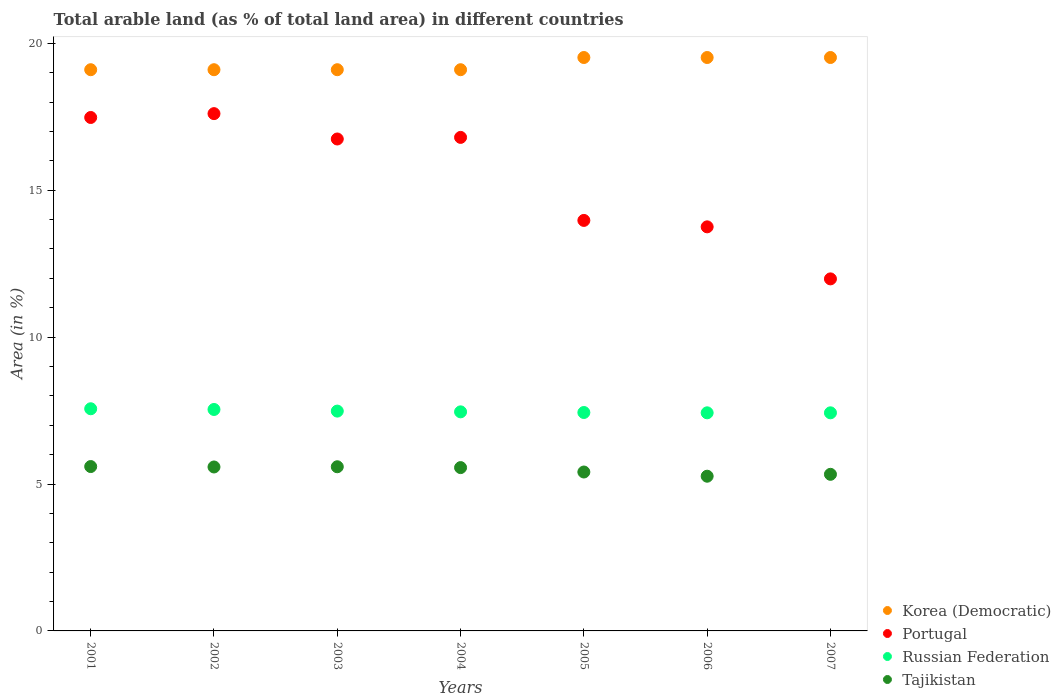What is the percentage of arable land in Korea (Democratic) in 2001?
Give a very brief answer. 19.1. Across all years, what is the maximum percentage of arable land in Tajikistan?
Give a very brief answer. 5.59. Across all years, what is the minimum percentage of arable land in Russian Federation?
Offer a terse response. 7.42. In which year was the percentage of arable land in Portugal maximum?
Offer a terse response. 2002. In which year was the percentage of arable land in Korea (Democratic) minimum?
Your response must be concise. 2001. What is the total percentage of arable land in Tajikistan in the graph?
Make the answer very short. 38.33. What is the difference between the percentage of arable land in Russian Federation in 2006 and that in 2007?
Give a very brief answer. 0. What is the difference between the percentage of arable land in Russian Federation in 2004 and the percentage of arable land in Portugal in 2001?
Keep it short and to the point. -10.02. What is the average percentage of arable land in Russian Federation per year?
Give a very brief answer. 7.47. In the year 2007, what is the difference between the percentage of arable land in Portugal and percentage of arable land in Korea (Democratic)?
Ensure brevity in your answer.  -7.53. In how many years, is the percentage of arable land in Russian Federation greater than 9 %?
Offer a terse response. 0. What is the ratio of the percentage of arable land in Korea (Democratic) in 2004 to that in 2005?
Your answer should be compact. 0.98. Is the percentage of arable land in Russian Federation in 2004 less than that in 2006?
Your answer should be very brief. No. What is the difference between the highest and the second highest percentage of arable land in Tajikistan?
Make the answer very short. 0.01. What is the difference between the highest and the lowest percentage of arable land in Tajikistan?
Keep it short and to the point. 0.33. Does the percentage of arable land in Russian Federation monotonically increase over the years?
Provide a short and direct response. No. Is the percentage of arable land in Tajikistan strictly less than the percentage of arable land in Russian Federation over the years?
Your response must be concise. Yes. What is the difference between two consecutive major ticks on the Y-axis?
Provide a succinct answer. 5. Does the graph contain any zero values?
Ensure brevity in your answer.  No. Where does the legend appear in the graph?
Offer a terse response. Bottom right. How many legend labels are there?
Your answer should be compact. 4. What is the title of the graph?
Your answer should be very brief. Total arable land (as % of total land area) in different countries. What is the label or title of the Y-axis?
Ensure brevity in your answer.  Area (in %). What is the Area (in %) in Korea (Democratic) in 2001?
Your answer should be compact. 19.1. What is the Area (in %) of Portugal in 2001?
Offer a very short reply. 17.48. What is the Area (in %) in Russian Federation in 2001?
Offer a very short reply. 7.56. What is the Area (in %) in Tajikistan in 2001?
Keep it short and to the point. 5.59. What is the Area (in %) in Korea (Democratic) in 2002?
Keep it short and to the point. 19.1. What is the Area (in %) of Portugal in 2002?
Your response must be concise. 17.61. What is the Area (in %) of Russian Federation in 2002?
Your answer should be very brief. 7.54. What is the Area (in %) of Tajikistan in 2002?
Offer a very short reply. 5.58. What is the Area (in %) in Korea (Democratic) in 2003?
Keep it short and to the point. 19.1. What is the Area (in %) in Portugal in 2003?
Give a very brief answer. 16.74. What is the Area (in %) of Russian Federation in 2003?
Provide a succinct answer. 7.48. What is the Area (in %) of Tajikistan in 2003?
Your answer should be very brief. 5.59. What is the Area (in %) in Korea (Democratic) in 2004?
Ensure brevity in your answer.  19.1. What is the Area (in %) of Portugal in 2004?
Keep it short and to the point. 16.8. What is the Area (in %) of Russian Federation in 2004?
Offer a very short reply. 7.46. What is the Area (in %) in Tajikistan in 2004?
Your answer should be compact. 5.56. What is the Area (in %) in Korea (Democratic) in 2005?
Make the answer very short. 19.52. What is the Area (in %) of Portugal in 2005?
Provide a succinct answer. 13.97. What is the Area (in %) of Russian Federation in 2005?
Ensure brevity in your answer.  7.43. What is the Area (in %) in Tajikistan in 2005?
Give a very brief answer. 5.41. What is the Area (in %) in Korea (Democratic) in 2006?
Provide a succinct answer. 19.52. What is the Area (in %) of Portugal in 2006?
Offer a very short reply. 13.75. What is the Area (in %) in Russian Federation in 2006?
Your response must be concise. 7.42. What is the Area (in %) in Tajikistan in 2006?
Your response must be concise. 5.27. What is the Area (in %) in Korea (Democratic) in 2007?
Give a very brief answer. 19.52. What is the Area (in %) in Portugal in 2007?
Ensure brevity in your answer.  11.98. What is the Area (in %) of Russian Federation in 2007?
Ensure brevity in your answer.  7.42. What is the Area (in %) in Tajikistan in 2007?
Offer a very short reply. 5.33. Across all years, what is the maximum Area (in %) in Korea (Democratic)?
Your answer should be compact. 19.52. Across all years, what is the maximum Area (in %) of Portugal?
Your response must be concise. 17.61. Across all years, what is the maximum Area (in %) in Russian Federation?
Provide a succinct answer. 7.56. Across all years, what is the maximum Area (in %) in Tajikistan?
Provide a short and direct response. 5.59. Across all years, what is the minimum Area (in %) of Korea (Democratic)?
Offer a terse response. 19.1. Across all years, what is the minimum Area (in %) of Portugal?
Provide a short and direct response. 11.98. Across all years, what is the minimum Area (in %) in Russian Federation?
Offer a very short reply. 7.42. Across all years, what is the minimum Area (in %) in Tajikistan?
Ensure brevity in your answer.  5.27. What is the total Area (in %) of Korea (Democratic) in the graph?
Offer a terse response. 134.96. What is the total Area (in %) in Portugal in the graph?
Offer a terse response. 108.33. What is the total Area (in %) of Russian Federation in the graph?
Your answer should be very brief. 52.32. What is the total Area (in %) of Tajikistan in the graph?
Your response must be concise. 38.33. What is the difference between the Area (in %) in Portugal in 2001 and that in 2002?
Your response must be concise. -0.13. What is the difference between the Area (in %) of Russian Federation in 2001 and that in 2002?
Provide a succinct answer. 0.02. What is the difference between the Area (in %) in Tajikistan in 2001 and that in 2002?
Your answer should be compact. 0.01. What is the difference between the Area (in %) of Korea (Democratic) in 2001 and that in 2003?
Make the answer very short. 0. What is the difference between the Area (in %) of Portugal in 2001 and that in 2003?
Ensure brevity in your answer.  0.73. What is the difference between the Area (in %) in Russian Federation in 2001 and that in 2003?
Keep it short and to the point. 0.08. What is the difference between the Area (in %) of Tajikistan in 2001 and that in 2003?
Ensure brevity in your answer.  0.01. What is the difference between the Area (in %) of Korea (Democratic) in 2001 and that in 2004?
Your answer should be compact. 0. What is the difference between the Area (in %) of Portugal in 2001 and that in 2004?
Make the answer very short. 0.68. What is the difference between the Area (in %) in Russian Federation in 2001 and that in 2004?
Your response must be concise. 0.1. What is the difference between the Area (in %) of Tajikistan in 2001 and that in 2004?
Make the answer very short. 0.04. What is the difference between the Area (in %) in Korea (Democratic) in 2001 and that in 2005?
Your response must be concise. -0.42. What is the difference between the Area (in %) of Portugal in 2001 and that in 2005?
Offer a terse response. 3.5. What is the difference between the Area (in %) of Russian Federation in 2001 and that in 2005?
Provide a succinct answer. 0.13. What is the difference between the Area (in %) of Tajikistan in 2001 and that in 2005?
Ensure brevity in your answer.  0.19. What is the difference between the Area (in %) of Korea (Democratic) in 2001 and that in 2006?
Offer a terse response. -0.42. What is the difference between the Area (in %) in Portugal in 2001 and that in 2006?
Ensure brevity in your answer.  3.72. What is the difference between the Area (in %) in Russian Federation in 2001 and that in 2006?
Ensure brevity in your answer.  0.14. What is the difference between the Area (in %) of Tajikistan in 2001 and that in 2006?
Offer a terse response. 0.33. What is the difference between the Area (in %) in Korea (Democratic) in 2001 and that in 2007?
Give a very brief answer. -0.42. What is the difference between the Area (in %) in Portugal in 2001 and that in 2007?
Your answer should be compact. 5.49. What is the difference between the Area (in %) in Russian Federation in 2001 and that in 2007?
Provide a succinct answer. 0.14. What is the difference between the Area (in %) in Tajikistan in 2001 and that in 2007?
Provide a short and direct response. 0.26. What is the difference between the Area (in %) of Portugal in 2002 and that in 2003?
Your answer should be compact. 0.86. What is the difference between the Area (in %) of Russian Federation in 2002 and that in 2003?
Provide a short and direct response. 0.06. What is the difference between the Area (in %) of Tajikistan in 2002 and that in 2003?
Make the answer very short. -0.01. What is the difference between the Area (in %) of Korea (Democratic) in 2002 and that in 2004?
Offer a very short reply. 0. What is the difference between the Area (in %) of Portugal in 2002 and that in 2004?
Provide a succinct answer. 0.81. What is the difference between the Area (in %) in Russian Federation in 2002 and that in 2004?
Provide a short and direct response. 0.08. What is the difference between the Area (in %) in Tajikistan in 2002 and that in 2004?
Your answer should be very brief. 0.02. What is the difference between the Area (in %) in Korea (Democratic) in 2002 and that in 2005?
Provide a succinct answer. -0.42. What is the difference between the Area (in %) in Portugal in 2002 and that in 2005?
Keep it short and to the point. 3.63. What is the difference between the Area (in %) of Russian Federation in 2002 and that in 2005?
Your answer should be compact. 0.1. What is the difference between the Area (in %) in Tajikistan in 2002 and that in 2005?
Provide a succinct answer. 0.17. What is the difference between the Area (in %) in Korea (Democratic) in 2002 and that in 2006?
Make the answer very short. -0.42. What is the difference between the Area (in %) in Portugal in 2002 and that in 2006?
Offer a very short reply. 3.85. What is the difference between the Area (in %) in Russian Federation in 2002 and that in 2006?
Your response must be concise. 0.11. What is the difference between the Area (in %) of Tajikistan in 2002 and that in 2006?
Make the answer very short. 0.31. What is the difference between the Area (in %) of Korea (Democratic) in 2002 and that in 2007?
Offer a terse response. -0.42. What is the difference between the Area (in %) of Portugal in 2002 and that in 2007?
Your answer should be very brief. 5.62. What is the difference between the Area (in %) of Russian Federation in 2002 and that in 2007?
Your answer should be compact. 0.11. What is the difference between the Area (in %) of Tajikistan in 2002 and that in 2007?
Offer a terse response. 0.25. What is the difference between the Area (in %) of Korea (Democratic) in 2003 and that in 2004?
Ensure brevity in your answer.  0. What is the difference between the Area (in %) in Portugal in 2003 and that in 2004?
Give a very brief answer. -0.05. What is the difference between the Area (in %) of Russian Federation in 2003 and that in 2004?
Offer a very short reply. 0.03. What is the difference between the Area (in %) in Tajikistan in 2003 and that in 2004?
Make the answer very short. 0.03. What is the difference between the Area (in %) in Korea (Democratic) in 2003 and that in 2005?
Keep it short and to the point. -0.42. What is the difference between the Area (in %) in Portugal in 2003 and that in 2005?
Your answer should be compact. 2.77. What is the difference between the Area (in %) in Russian Federation in 2003 and that in 2005?
Your response must be concise. 0.05. What is the difference between the Area (in %) in Tajikistan in 2003 and that in 2005?
Your answer should be very brief. 0.18. What is the difference between the Area (in %) in Korea (Democratic) in 2003 and that in 2006?
Offer a very short reply. -0.42. What is the difference between the Area (in %) of Portugal in 2003 and that in 2006?
Give a very brief answer. 2.99. What is the difference between the Area (in %) in Russian Federation in 2003 and that in 2006?
Make the answer very short. 0.06. What is the difference between the Area (in %) in Tajikistan in 2003 and that in 2006?
Ensure brevity in your answer.  0.32. What is the difference between the Area (in %) of Korea (Democratic) in 2003 and that in 2007?
Provide a short and direct response. -0.42. What is the difference between the Area (in %) in Portugal in 2003 and that in 2007?
Your response must be concise. 4.76. What is the difference between the Area (in %) in Russian Federation in 2003 and that in 2007?
Offer a terse response. 0.06. What is the difference between the Area (in %) in Tajikistan in 2003 and that in 2007?
Provide a succinct answer. 0.26. What is the difference between the Area (in %) in Korea (Democratic) in 2004 and that in 2005?
Offer a terse response. -0.42. What is the difference between the Area (in %) in Portugal in 2004 and that in 2005?
Your answer should be compact. 2.83. What is the difference between the Area (in %) of Russian Federation in 2004 and that in 2005?
Provide a succinct answer. 0.02. What is the difference between the Area (in %) in Tajikistan in 2004 and that in 2005?
Your answer should be compact. 0.15. What is the difference between the Area (in %) in Korea (Democratic) in 2004 and that in 2006?
Your response must be concise. -0.42. What is the difference between the Area (in %) of Portugal in 2004 and that in 2006?
Ensure brevity in your answer.  3.04. What is the difference between the Area (in %) in Russian Federation in 2004 and that in 2006?
Give a very brief answer. 0.03. What is the difference between the Area (in %) of Tajikistan in 2004 and that in 2006?
Offer a terse response. 0.29. What is the difference between the Area (in %) in Korea (Democratic) in 2004 and that in 2007?
Offer a terse response. -0.42. What is the difference between the Area (in %) in Portugal in 2004 and that in 2007?
Provide a succinct answer. 4.82. What is the difference between the Area (in %) of Tajikistan in 2004 and that in 2007?
Make the answer very short. 0.23. What is the difference between the Area (in %) of Korea (Democratic) in 2005 and that in 2006?
Provide a succinct answer. 0. What is the difference between the Area (in %) in Portugal in 2005 and that in 2006?
Offer a very short reply. 0.22. What is the difference between the Area (in %) of Russian Federation in 2005 and that in 2006?
Ensure brevity in your answer.  0.01. What is the difference between the Area (in %) in Tajikistan in 2005 and that in 2006?
Provide a succinct answer. 0.14. What is the difference between the Area (in %) of Portugal in 2005 and that in 2007?
Your answer should be very brief. 1.99. What is the difference between the Area (in %) in Russian Federation in 2005 and that in 2007?
Provide a short and direct response. 0.01. What is the difference between the Area (in %) of Tajikistan in 2005 and that in 2007?
Offer a very short reply. 0.08. What is the difference between the Area (in %) of Portugal in 2006 and that in 2007?
Ensure brevity in your answer.  1.77. What is the difference between the Area (in %) of Russian Federation in 2006 and that in 2007?
Your answer should be very brief. 0. What is the difference between the Area (in %) in Tajikistan in 2006 and that in 2007?
Your response must be concise. -0.06. What is the difference between the Area (in %) in Korea (Democratic) in 2001 and the Area (in %) in Portugal in 2002?
Provide a succinct answer. 1.49. What is the difference between the Area (in %) of Korea (Democratic) in 2001 and the Area (in %) of Russian Federation in 2002?
Your answer should be compact. 11.56. What is the difference between the Area (in %) of Korea (Democratic) in 2001 and the Area (in %) of Tajikistan in 2002?
Provide a succinct answer. 13.52. What is the difference between the Area (in %) in Portugal in 2001 and the Area (in %) in Russian Federation in 2002?
Offer a terse response. 9.94. What is the difference between the Area (in %) in Portugal in 2001 and the Area (in %) in Tajikistan in 2002?
Your answer should be compact. 11.9. What is the difference between the Area (in %) in Russian Federation in 2001 and the Area (in %) in Tajikistan in 2002?
Offer a very short reply. 1.98. What is the difference between the Area (in %) in Korea (Democratic) in 2001 and the Area (in %) in Portugal in 2003?
Make the answer very short. 2.36. What is the difference between the Area (in %) of Korea (Democratic) in 2001 and the Area (in %) of Russian Federation in 2003?
Provide a short and direct response. 11.62. What is the difference between the Area (in %) in Korea (Democratic) in 2001 and the Area (in %) in Tajikistan in 2003?
Your answer should be compact. 13.51. What is the difference between the Area (in %) in Portugal in 2001 and the Area (in %) in Russian Federation in 2003?
Ensure brevity in your answer.  9.99. What is the difference between the Area (in %) of Portugal in 2001 and the Area (in %) of Tajikistan in 2003?
Offer a terse response. 11.89. What is the difference between the Area (in %) of Russian Federation in 2001 and the Area (in %) of Tajikistan in 2003?
Keep it short and to the point. 1.97. What is the difference between the Area (in %) in Korea (Democratic) in 2001 and the Area (in %) in Portugal in 2004?
Your answer should be very brief. 2.3. What is the difference between the Area (in %) of Korea (Democratic) in 2001 and the Area (in %) of Russian Federation in 2004?
Give a very brief answer. 11.64. What is the difference between the Area (in %) of Korea (Democratic) in 2001 and the Area (in %) of Tajikistan in 2004?
Your answer should be compact. 13.54. What is the difference between the Area (in %) of Portugal in 2001 and the Area (in %) of Russian Federation in 2004?
Provide a short and direct response. 10.02. What is the difference between the Area (in %) in Portugal in 2001 and the Area (in %) in Tajikistan in 2004?
Provide a succinct answer. 11.92. What is the difference between the Area (in %) of Russian Federation in 2001 and the Area (in %) of Tajikistan in 2004?
Your response must be concise. 2. What is the difference between the Area (in %) of Korea (Democratic) in 2001 and the Area (in %) of Portugal in 2005?
Ensure brevity in your answer.  5.13. What is the difference between the Area (in %) of Korea (Democratic) in 2001 and the Area (in %) of Russian Federation in 2005?
Offer a terse response. 11.67. What is the difference between the Area (in %) in Korea (Democratic) in 2001 and the Area (in %) in Tajikistan in 2005?
Your response must be concise. 13.69. What is the difference between the Area (in %) in Portugal in 2001 and the Area (in %) in Russian Federation in 2005?
Provide a succinct answer. 10.04. What is the difference between the Area (in %) in Portugal in 2001 and the Area (in %) in Tajikistan in 2005?
Make the answer very short. 12.07. What is the difference between the Area (in %) of Russian Federation in 2001 and the Area (in %) of Tajikistan in 2005?
Your answer should be very brief. 2.15. What is the difference between the Area (in %) of Korea (Democratic) in 2001 and the Area (in %) of Portugal in 2006?
Offer a very short reply. 5.35. What is the difference between the Area (in %) of Korea (Democratic) in 2001 and the Area (in %) of Russian Federation in 2006?
Offer a very short reply. 11.68. What is the difference between the Area (in %) in Korea (Democratic) in 2001 and the Area (in %) in Tajikistan in 2006?
Ensure brevity in your answer.  13.84. What is the difference between the Area (in %) of Portugal in 2001 and the Area (in %) of Russian Federation in 2006?
Keep it short and to the point. 10.05. What is the difference between the Area (in %) of Portugal in 2001 and the Area (in %) of Tajikistan in 2006?
Your response must be concise. 12.21. What is the difference between the Area (in %) of Russian Federation in 2001 and the Area (in %) of Tajikistan in 2006?
Provide a succinct answer. 2.3. What is the difference between the Area (in %) in Korea (Democratic) in 2001 and the Area (in %) in Portugal in 2007?
Make the answer very short. 7.12. What is the difference between the Area (in %) in Korea (Democratic) in 2001 and the Area (in %) in Russian Federation in 2007?
Your answer should be compact. 11.68. What is the difference between the Area (in %) in Korea (Democratic) in 2001 and the Area (in %) in Tajikistan in 2007?
Provide a short and direct response. 13.77. What is the difference between the Area (in %) in Portugal in 2001 and the Area (in %) in Russian Federation in 2007?
Your answer should be very brief. 10.05. What is the difference between the Area (in %) of Portugal in 2001 and the Area (in %) of Tajikistan in 2007?
Offer a very short reply. 12.15. What is the difference between the Area (in %) of Russian Federation in 2001 and the Area (in %) of Tajikistan in 2007?
Provide a succinct answer. 2.23. What is the difference between the Area (in %) in Korea (Democratic) in 2002 and the Area (in %) in Portugal in 2003?
Provide a succinct answer. 2.36. What is the difference between the Area (in %) in Korea (Democratic) in 2002 and the Area (in %) in Russian Federation in 2003?
Offer a terse response. 11.62. What is the difference between the Area (in %) of Korea (Democratic) in 2002 and the Area (in %) of Tajikistan in 2003?
Keep it short and to the point. 13.51. What is the difference between the Area (in %) of Portugal in 2002 and the Area (in %) of Russian Federation in 2003?
Keep it short and to the point. 10.12. What is the difference between the Area (in %) of Portugal in 2002 and the Area (in %) of Tajikistan in 2003?
Provide a succinct answer. 12.02. What is the difference between the Area (in %) in Russian Federation in 2002 and the Area (in %) in Tajikistan in 2003?
Your response must be concise. 1.95. What is the difference between the Area (in %) in Korea (Democratic) in 2002 and the Area (in %) in Portugal in 2004?
Offer a terse response. 2.3. What is the difference between the Area (in %) in Korea (Democratic) in 2002 and the Area (in %) in Russian Federation in 2004?
Your answer should be compact. 11.64. What is the difference between the Area (in %) in Korea (Democratic) in 2002 and the Area (in %) in Tajikistan in 2004?
Provide a short and direct response. 13.54. What is the difference between the Area (in %) of Portugal in 2002 and the Area (in %) of Russian Federation in 2004?
Keep it short and to the point. 10.15. What is the difference between the Area (in %) in Portugal in 2002 and the Area (in %) in Tajikistan in 2004?
Your response must be concise. 12.05. What is the difference between the Area (in %) in Russian Federation in 2002 and the Area (in %) in Tajikistan in 2004?
Make the answer very short. 1.98. What is the difference between the Area (in %) of Korea (Democratic) in 2002 and the Area (in %) of Portugal in 2005?
Your answer should be compact. 5.13. What is the difference between the Area (in %) in Korea (Democratic) in 2002 and the Area (in %) in Russian Federation in 2005?
Ensure brevity in your answer.  11.67. What is the difference between the Area (in %) in Korea (Democratic) in 2002 and the Area (in %) in Tajikistan in 2005?
Ensure brevity in your answer.  13.69. What is the difference between the Area (in %) of Portugal in 2002 and the Area (in %) of Russian Federation in 2005?
Make the answer very short. 10.17. What is the difference between the Area (in %) of Portugal in 2002 and the Area (in %) of Tajikistan in 2005?
Give a very brief answer. 12.2. What is the difference between the Area (in %) in Russian Federation in 2002 and the Area (in %) in Tajikistan in 2005?
Provide a succinct answer. 2.13. What is the difference between the Area (in %) in Korea (Democratic) in 2002 and the Area (in %) in Portugal in 2006?
Your answer should be compact. 5.35. What is the difference between the Area (in %) in Korea (Democratic) in 2002 and the Area (in %) in Russian Federation in 2006?
Offer a terse response. 11.68. What is the difference between the Area (in %) in Korea (Democratic) in 2002 and the Area (in %) in Tajikistan in 2006?
Provide a short and direct response. 13.84. What is the difference between the Area (in %) in Portugal in 2002 and the Area (in %) in Russian Federation in 2006?
Provide a succinct answer. 10.18. What is the difference between the Area (in %) in Portugal in 2002 and the Area (in %) in Tajikistan in 2006?
Offer a terse response. 12.34. What is the difference between the Area (in %) of Russian Federation in 2002 and the Area (in %) of Tajikistan in 2006?
Offer a very short reply. 2.27. What is the difference between the Area (in %) in Korea (Democratic) in 2002 and the Area (in %) in Portugal in 2007?
Your answer should be compact. 7.12. What is the difference between the Area (in %) in Korea (Democratic) in 2002 and the Area (in %) in Russian Federation in 2007?
Your answer should be compact. 11.68. What is the difference between the Area (in %) in Korea (Democratic) in 2002 and the Area (in %) in Tajikistan in 2007?
Provide a succinct answer. 13.77. What is the difference between the Area (in %) of Portugal in 2002 and the Area (in %) of Russian Federation in 2007?
Make the answer very short. 10.18. What is the difference between the Area (in %) in Portugal in 2002 and the Area (in %) in Tajikistan in 2007?
Offer a terse response. 12.28. What is the difference between the Area (in %) in Russian Federation in 2002 and the Area (in %) in Tajikistan in 2007?
Give a very brief answer. 2.21. What is the difference between the Area (in %) of Korea (Democratic) in 2003 and the Area (in %) of Portugal in 2004?
Make the answer very short. 2.3. What is the difference between the Area (in %) of Korea (Democratic) in 2003 and the Area (in %) of Russian Federation in 2004?
Keep it short and to the point. 11.64. What is the difference between the Area (in %) of Korea (Democratic) in 2003 and the Area (in %) of Tajikistan in 2004?
Provide a short and direct response. 13.54. What is the difference between the Area (in %) in Portugal in 2003 and the Area (in %) in Russian Federation in 2004?
Provide a succinct answer. 9.29. What is the difference between the Area (in %) of Portugal in 2003 and the Area (in %) of Tajikistan in 2004?
Offer a very short reply. 11.18. What is the difference between the Area (in %) in Russian Federation in 2003 and the Area (in %) in Tajikistan in 2004?
Offer a terse response. 1.92. What is the difference between the Area (in %) in Korea (Democratic) in 2003 and the Area (in %) in Portugal in 2005?
Give a very brief answer. 5.13. What is the difference between the Area (in %) in Korea (Democratic) in 2003 and the Area (in %) in Russian Federation in 2005?
Provide a short and direct response. 11.67. What is the difference between the Area (in %) in Korea (Democratic) in 2003 and the Area (in %) in Tajikistan in 2005?
Your response must be concise. 13.69. What is the difference between the Area (in %) of Portugal in 2003 and the Area (in %) of Russian Federation in 2005?
Make the answer very short. 9.31. What is the difference between the Area (in %) of Portugal in 2003 and the Area (in %) of Tajikistan in 2005?
Your response must be concise. 11.33. What is the difference between the Area (in %) in Russian Federation in 2003 and the Area (in %) in Tajikistan in 2005?
Provide a succinct answer. 2.07. What is the difference between the Area (in %) of Korea (Democratic) in 2003 and the Area (in %) of Portugal in 2006?
Offer a terse response. 5.35. What is the difference between the Area (in %) of Korea (Democratic) in 2003 and the Area (in %) of Russian Federation in 2006?
Your answer should be very brief. 11.68. What is the difference between the Area (in %) in Korea (Democratic) in 2003 and the Area (in %) in Tajikistan in 2006?
Offer a very short reply. 13.84. What is the difference between the Area (in %) of Portugal in 2003 and the Area (in %) of Russian Federation in 2006?
Provide a succinct answer. 9.32. What is the difference between the Area (in %) of Portugal in 2003 and the Area (in %) of Tajikistan in 2006?
Your answer should be very brief. 11.48. What is the difference between the Area (in %) in Russian Federation in 2003 and the Area (in %) in Tajikistan in 2006?
Your response must be concise. 2.22. What is the difference between the Area (in %) of Korea (Democratic) in 2003 and the Area (in %) of Portugal in 2007?
Keep it short and to the point. 7.12. What is the difference between the Area (in %) in Korea (Democratic) in 2003 and the Area (in %) in Russian Federation in 2007?
Ensure brevity in your answer.  11.68. What is the difference between the Area (in %) in Korea (Democratic) in 2003 and the Area (in %) in Tajikistan in 2007?
Give a very brief answer. 13.77. What is the difference between the Area (in %) in Portugal in 2003 and the Area (in %) in Russian Federation in 2007?
Keep it short and to the point. 9.32. What is the difference between the Area (in %) of Portugal in 2003 and the Area (in %) of Tajikistan in 2007?
Provide a short and direct response. 11.41. What is the difference between the Area (in %) in Russian Federation in 2003 and the Area (in %) in Tajikistan in 2007?
Your answer should be very brief. 2.15. What is the difference between the Area (in %) of Korea (Democratic) in 2004 and the Area (in %) of Portugal in 2005?
Your answer should be very brief. 5.13. What is the difference between the Area (in %) in Korea (Democratic) in 2004 and the Area (in %) in Russian Federation in 2005?
Offer a very short reply. 11.67. What is the difference between the Area (in %) in Korea (Democratic) in 2004 and the Area (in %) in Tajikistan in 2005?
Offer a very short reply. 13.69. What is the difference between the Area (in %) of Portugal in 2004 and the Area (in %) of Russian Federation in 2005?
Provide a short and direct response. 9.36. What is the difference between the Area (in %) of Portugal in 2004 and the Area (in %) of Tajikistan in 2005?
Make the answer very short. 11.39. What is the difference between the Area (in %) in Russian Federation in 2004 and the Area (in %) in Tajikistan in 2005?
Ensure brevity in your answer.  2.05. What is the difference between the Area (in %) of Korea (Democratic) in 2004 and the Area (in %) of Portugal in 2006?
Provide a short and direct response. 5.35. What is the difference between the Area (in %) in Korea (Democratic) in 2004 and the Area (in %) in Russian Federation in 2006?
Give a very brief answer. 11.68. What is the difference between the Area (in %) in Korea (Democratic) in 2004 and the Area (in %) in Tajikistan in 2006?
Your answer should be compact. 13.84. What is the difference between the Area (in %) in Portugal in 2004 and the Area (in %) in Russian Federation in 2006?
Offer a terse response. 9.37. What is the difference between the Area (in %) of Portugal in 2004 and the Area (in %) of Tajikistan in 2006?
Offer a terse response. 11.53. What is the difference between the Area (in %) in Russian Federation in 2004 and the Area (in %) in Tajikistan in 2006?
Offer a very short reply. 2.19. What is the difference between the Area (in %) of Korea (Democratic) in 2004 and the Area (in %) of Portugal in 2007?
Offer a terse response. 7.12. What is the difference between the Area (in %) of Korea (Democratic) in 2004 and the Area (in %) of Russian Federation in 2007?
Your answer should be compact. 11.68. What is the difference between the Area (in %) in Korea (Democratic) in 2004 and the Area (in %) in Tajikistan in 2007?
Keep it short and to the point. 13.77. What is the difference between the Area (in %) of Portugal in 2004 and the Area (in %) of Russian Federation in 2007?
Offer a very short reply. 9.37. What is the difference between the Area (in %) of Portugal in 2004 and the Area (in %) of Tajikistan in 2007?
Your answer should be compact. 11.47. What is the difference between the Area (in %) in Russian Federation in 2004 and the Area (in %) in Tajikistan in 2007?
Offer a very short reply. 2.13. What is the difference between the Area (in %) in Korea (Democratic) in 2005 and the Area (in %) in Portugal in 2006?
Ensure brevity in your answer.  5.76. What is the difference between the Area (in %) in Korea (Democratic) in 2005 and the Area (in %) in Russian Federation in 2006?
Provide a short and direct response. 12.09. What is the difference between the Area (in %) of Korea (Democratic) in 2005 and the Area (in %) of Tajikistan in 2006?
Provide a succinct answer. 14.25. What is the difference between the Area (in %) of Portugal in 2005 and the Area (in %) of Russian Federation in 2006?
Your response must be concise. 6.55. What is the difference between the Area (in %) in Portugal in 2005 and the Area (in %) in Tajikistan in 2006?
Give a very brief answer. 8.71. What is the difference between the Area (in %) in Russian Federation in 2005 and the Area (in %) in Tajikistan in 2006?
Offer a terse response. 2.17. What is the difference between the Area (in %) of Korea (Democratic) in 2005 and the Area (in %) of Portugal in 2007?
Ensure brevity in your answer.  7.53. What is the difference between the Area (in %) of Korea (Democratic) in 2005 and the Area (in %) of Russian Federation in 2007?
Ensure brevity in your answer.  12.09. What is the difference between the Area (in %) in Korea (Democratic) in 2005 and the Area (in %) in Tajikistan in 2007?
Keep it short and to the point. 14.19. What is the difference between the Area (in %) in Portugal in 2005 and the Area (in %) in Russian Federation in 2007?
Ensure brevity in your answer.  6.55. What is the difference between the Area (in %) in Portugal in 2005 and the Area (in %) in Tajikistan in 2007?
Give a very brief answer. 8.64. What is the difference between the Area (in %) of Russian Federation in 2005 and the Area (in %) of Tajikistan in 2007?
Offer a terse response. 2.1. What is the difference between the Area (in %) in Korea (Democratic) in 2006 and the Area (in %) in Portugal in 2007?
Your response must be concise. 7.53. What is the difference between the Area (in %) in Korea (Democratic) in 2006 and the Area (in %) in Russian Federation in 2007?
Your response must be concise. 12.09. What is the difference between the Area (in %) in Korea (Democratic) in 2006 and the Area (in %) in Tajikistan in 2007?
Offer a terse response. 14.19. What is the difference between the Area (in %) of Portugal in 2006 and the Area (in %) of Russian Federation in 2007?
Provide a short and direct response. 6.33. What is the difference between the Area (in %) of Portugal in 2006 and the Area (in %) of Tajikistan in 2007?
Your response must be concise. 8.42. What is the difference between the Area (in %) in Russian Federation in 2006 and the Area (in %) in Tajikistan in 2007?
Provide a succinct answer. 2.09. What is the average Area (in %) of Korea (Democratic) per year?
Your response must be concise. 19.28. What is the average Area (in %) in Portugal per year?
Make the answer very short. 15.48. What is the average Area (in %) of Russian Federation per year?
Offer a terse response. 7.47. What is the average Area (in %) of Tajikistan per year?
Offer a terse response. 5.47. In the year 2001, what is the difference between the Area (in %) in Korea (Democratic) and Area (in %) in Portugal?
Ensure brevity in your answer.  1.63. In the year 2001, what is the difference between the Area (in %) in Korea (Democratic) and Area (in %) in Russian Federation?
Provide a succinct answer. 11.54. In the year 2001, what is the difference between the Area (in %) in Korea (Democratic) and Area (in %) in Tajikistan?
Provide a short and direct response. 13.51. In the year 2001, what is the difference between the Area (in %) in Portugal and Area (in %) in Russian Federation?
Provide a short and direct response. 9.91. In the year 2001, what is the difference between the Area (in %) in Portugal and Area (in %) in Tajikistan?
Provide a succinct answer. 11.88. In the year 2001, what is the difference between the Area (in %) in Russian Federation and Area (in %) in Tajikistan?
Ensure brevity in your answer.  1.97. In the year 2002, what is the difference between the Area (in %) in Korea (Democratic) and Area (in %) in Portugal?
Your answer should be compact. 1.49. In the year 2002, what is the difference between the Area (in %) of Korea (Democratic) and Area (in %) of Russian Federation?
Ensure brevity in your answer.  11.56. In the year 2002, what is the difference between the Area (in %) of Korea (Democratic) and Area (in %) of Tajikistan?
Keep it short and to the point. 13.52. In the year 2002, what is the difference between the Area (in %) in Portugal and Area (in %) in Russian Federation?
Provide a short and direct response. 10.07. In the year 2002, what is the difference between the Area (in %) of Portugal and Area (in %) of Tajikistan?
Your response must be concise. 12.03. In the year 2002, what is the difference between the Area (in %) of Russian Federation and Area (in %) of Tajikistan?
Ensure brevity in your answer.  1.96. In the year 2003, what is the difference between the Area (in %) in Korea (Democratic) and Area (in %) in Portugal?
Provide a succinct answer. 2.36. In the year 2003, what is the difference between the Area (in %) in Korea (Democratic) and Area (in %) in Russian Federation?
Make the answer very short. 11.62. In the year 2003, what is the difference between the Area (in %) of Korea (Democratic) and Area (in %) of Tajikistan?
Offer a terse response. 13.51. In the year 2003, what is the difference between the Area (in %) in Portugal and Area (in %) in Russian Federation?
Make the answer very short. 9.26. In the year 2003, what is the difference between the Area (in %) in Portugal and Area (in %) in Tajikistan?
Offer a terse response. 11.16. In the year 2003, what is the difference between the Area (in %) of Russian Federation and Area (in %) of Tajikistan?
Keep it short and to the point. 1.89. In the year 2004, what is the difference between the Area (in %) of Korea (Democratic) and Area (in %) of Portugal?
Keep it short and to the point. 2.3. In the year 2004, what is the difference between the Area (in %) in Korea (Democratic) and Area (in %) in Russian Federation?
Your response must be concise. 11.64. In the year 2004, what is the difference between the Area (in %) of Korea (Democratic) and Area (in %) of Tajikistan?
Give a very brief answer. 13.54. In the year 2004, what is the difference between the Area (in %) in Portugal and Area (in %) in Russian Federation?
Offer a very short reply. 9.34. In the year 2004, what is the difference between the Area (in %) of Portugal and Area (in %) of Tajikistan?
Offer a terse response. 11.24. In the year 2004, what is the difference between the Area (in %) in Russian Federation and Area (in %) in Tajikistan?
Your answer should be compact. 1.9. In the year 2005, what is the difference between the Area (in %) in Korea (Democratic) and Area (in %) in Portugal?
Give a very brief answer. 5.54. In the year 2005, what is the difference between the Area (in %) in Korea (Democratic) and Area (in %) in Russian Federation?
Make the answer very short. 12.08. In the year 2005, what is the difference between the Area (in %) in Korea (Democratic) and Area (in %) in Tajikistan?
Make the answer very short. 14.11. In the year 2005, what is the difference between the Area (in %) of Portugal and Area (in %) of Russian Federation?
Make the answer very short. 6.54. In the year 2005, what is the difference between the Area (in %) of Portugal and Area (in %) of Tajikistan?
Your response must be concise. 8.56. In the year 2005, what is the difference between the Area (in %) in Russian Federation and Area (in %) in Tajikistan?
Offer a terse response. 2.03. In the year 2006, what is the difference between the Area (in %) of Korea (Democratic) and Area (in %) of Portugal?
Offer a terse response. 5.76. In the year 2006, what is the difference between the Area (in %) of Korea (Democratic) and Area (in %) of Russian Federation?
Provide a succinct answer. 12.09. In the year 2006, what is the difference between the Area (in %) of Korea (Democratic) and Area (in %) of Tajikistan?
Your answer should be very brief. 14.25. In the year 2006, what is the difference between the Area (in %) of Portugal and Area (in %) of Russian Federation?
Keep it short and to the point. 6.33. In the year 2006, what is the difference between the Area (in %) of Portugal and Area (in %) of Tajikistan?
Keep it short and to the point. 8.49. In the year 2006, what is the difference between the Area (in %) in Russian Federation and Area (in %) in Tajikistan?
Ensure brevity in your answer.  2.16. In the year 2007, what is the difference between the Area (in %) of Korea (Democratic) and Area (in %) of Portugal?
Ensure brevity in your answer.  7.53. In the year 2007, what is the difference between the Area (in %) in Korea (Democratic) and Area (in %) in Russian Federation?
Provide a short and direct response. 12.09. In the year 2007, what is the difference between the Area (in %) of Korea (Democratic) and Area (in %) of Tajikistan?
Provide a succinct answer. 14.19. In the year 2007, what is the difference between the Area (in %) of Portugal and Area (in %) of Russian Federation?
Provide a succinct answer. 4.56. In the year 2007, what is the difference between the Area (in %) in Portugal and Area (in %) in Tajikistan?
Offer a terse response. 6.65. In the year 2007, what is the difference between the Area (in %) of Russian Federation and Area (in %) of Tajikistan?
Make the answer very short. 2.09. What is the ratio of the Area (in %) of Korea (Democratic) in 2001 to that in 2002?
Ensure brevity in your answer.  1. What is the ratio of the Area (in %) in Portugal in 2001 to that in 2002?
Your response must be concise. 0.99. What is the ratio of the Area (in %) in Russian Federation in 2001 to that in 2002?
Your answer should be very brief. 1. What is the ratio of the Area (in %) in Tajikistan in 2001 to that in 2002?
Give a very brief answer. 1. What is the ratio of the Area (in %) of Korea (Democratic) in 2001 to that in 2003?
Keep it short and to the point. 1. What is the ratio of the Area (in %) in Portugal in 2001 to that in 2003?
Your answer should be very brief. 1.04. What is the ratio of the Area (in %) in Russian Federation in 2001 to that in 2003?
Provide a short and direct response. 1.01. What is the ratio of the Area (in %) in Tajikistan in 2001 to that in 2003?
Your response must be concise. 1. What is the ratio of the Area (in %) of Portugal in 2001 to that in 2004?
Your response must be concise. 1.04. What is the ratio of the Area (in %) of Russian Federation in 2001 to that in 2004?
Make the answer very short. 1.01. What is the ratio of the Area (in %) of Tajikistan in 2001 to that in 2004?
Your response must be concise. 1.01. What is the ratio of the Area (in %) in Korea (Democratic) in 2001 to that in 2005?
Your answer should be very brief. 0.98. What is the ratio of the Area (in %) in Portugal in 2001 to that in 2005?
Your answer should be compact. 1.25. What is the ratio of the Area (in %) of Russian Federation in 2001 to that in 2005?
Ensure brevity in your answer.  1.02. What is the ratio of the Area (in %) of Tajikistan in 2001 to that in 2005?
Your answer should be compact. 1.03. What is the ratio of the Area (in %) of Korea (Democratic) in 2001 to that in 2006?
Your response must be concise. 0.98. What is the ratio of the Area (in %) of Portugal in 2001 to that in 2006?
Your answer should be compact. 1.27. What is the ratio of the Area (in %) of Russian Federation in 2001 to that in 2006?
Offer a terse response. 1.02. What is the ratio of the Area (in %) of Tajikistan in 2001 to that in 2006?
Keep it short and to the point. 1.06. What is the ratio of the Area (in %) in Korea (Democratic) in 2001 to that in 2007?
Your answer should be compact. 0.98. What is the ratio of the Area (in %) of Portugal in 2001 to that in 2007?
Keep it short and to the point. 1.46. What is the ratio of the Area (in %) in Russian Federation in 2001 to that in 2007?
Keep it short and to the point. 1.02. What is the ratio of the Area (in %) in Tajikistan in 2001 to that in 2007?
Your answer should be very brief. 1.05. What is the ratio of the Area (in %) in Portugal in 2002 to that in 2003?
Provide a short and direct response. 1.05. What is the ratio of the Area (in %) in Russian Federation in 2002 to that in 2003?
Your answer should be very brief. 1.01. What is the ratio of the Area (in %) of Tajikistan in 2002 to that in 2003?
Provide a short and direct response. 1. What is the ratio of the Area (in %) of Portugal in 2002 to that in 2004?
Your response must be concise. 1.05. What is the ratio of the Area (in %) of Russian Federation in 2002 to that in 2004?
Your answer should be very brief. 1.01. What is the ratio of the Area (in %) in Tajikistan in 2002 to that in 2004?
Your answer should be compact. 1. What is the ratio of the Area (in %) of Korea (Democratic) in 2002 to that in 2005?
Your answer should be compact. 0.98. What is the ratio of the Area (in %) in Portugal in 2002 to that in 2005?
Make the answer very short. 1.26. What is the ratio of the Area (in %) in Russian Federation in 2002 to that in 2005?
Provide a succinct answer. 1.01. What is the ratio of the Area (in %) in Tajikistan in 2002 to that in 2005?
Make the answer very short. 1.03. What is the ratio of the Area (in %) of Korea (Democratic) in 2002 to that in 2006?
Provide a short and direct response. 0.98. What is the ratio of the Area (in %) in Portugal in 2002 to that in 2006?
Provide a short and direct response. 1.28. What is the ratio of the Area (in %) in Russian Federation in 2002 to that in 2006?
Offer a very short reply. 1.02. What is the ratio of the Area (in %) of Tajikistan in 2002 to that in 2006?
Offer a very short reply. 1.06. What is the ratio of the Area (in %) of Korea (Democratic) in 2002 to that in 2007?
Provide a short and direct response. 0.98. What is the ratio of the Area (in %) of Portugal in 2002 to that in 2007?
Offer a terse response. 1.47. What is the ratio of the Area (in %) in Russian Federation in 2002 to that in 2007?
Offer a very short reply. 1.02. What is the ratio of the Area (in %) in Tajikistan in 2002 to that in 2007?
Keep it short and to the point. 1.05. What is the ratio of the Area (in %) of Korea (Democratic) in 2003 to that in 2004?
Your response must be concise. 1. What is the ratio of the Area (in %) in Portugal in 2003 to that in 2004?
Your response must be concise. 1. What is the ratio of the Area (in %) in Korea (Democratic) in 2003 to that in 2005?
Your answer should be very brief. 0.98. What is the ratio of the Area (in %) of Portugal in 2003 to that in 2005?
Ensure brevity in your answer.  1.2. What is the ratio of the Area (in %) in Russian Federation in 2003 to that in 2005?
Ensure brevity in your answer.  1.01. What is the ratio of the Area (in %) of Tajikistan in 2003 to that in 2005?
Provide a short and direct response. 1.03. What is the ratio of the Area (in %) of Korea (Democratic) in 2003 to that in 2006?
Your answer should be compact. 0.98. What is the ratio of the Area (in %) of Portugal in 2003 to that in 2006?
Ensure brevity in your answer.  1.22. What is the ratio of the Area (in %) of Russian Federation in 2003 to that in 2006?
Give a very brief answer. 1.01. What is the ratio of the Area (in %) in Tajikistan in 2003 to that in 2006?
Offer a terse response. 1.06. What is the ratio of the Area (in %) in Korea (Democratic) in 2003 to that in 2007?
Ensure brevity in your answer.  0.98. What is the ratio of the Area (in %) in Portugal in 2003 to that in 2007?
Your response must be concise. 1.4. What is the ratio of the Area (in %) of Russian Federation in 2003 to that in 2007?
Make the answer very short. 1.01. What is the ratio of the Area (in %) of Tajikistan in 2003 to that in 2007?
Make the answer very short. 1.05. What is the ratio of the Area (in %) of Korea (Democratic) in 2004 to that in 2005?
Keep it short and to the point. 0.98. What is the ratio of the Area (in %) in Portugal in 2004 to that in 2005?
Offer a terse response. 1.2. What is the ratio of the Area (in %) in Russian Federation in 2004 to that in 2005?
Offer a terse response. 1. What is the ratio of the Area (in %) of Tajikistan in 2004 to that in 2005?
Your answer should be very brief. 1.03. What is the ratio of the Area (in %) of Korea (Democratic) in 2004 to that in 2006?
Keep it short and to the point. 0.98. What is the ratio of the Area (in %) of Portugal in 2004 to that in 2006?
Give a very brief answer. 1.22. What is the ratio of the Area (in %) of Russian Federation in 2004 to that in 2006?
Your response must be concise. 1. What is the ratio of the Area (in %) in Tajikistan in 2004 to that in 2006?
Provide a succinct answer. 1.06. What is the ratio of the Area (in %) in Korea (Democratic) in 2004 to that in 2007?
Keep it short and to the point. 0.98. What is the ratio of the Area (in %) in Portugal in 2004 to that in 2007?
Keep it short and to the point. 1.4. What is the ratio of the Area (in %) of Russian Federation in 2004 to that in 2007?
Keep it short and to the point. 1. What is the ratio of the Area (in %) in Tajikistan in 2004 to that in 2007?
Keep it short and to the point. 1.04. What is the ratio of the Area (in %) in Portugal in 2005 to that in 2006?
Provide a succinct answer. 1.02. What is the ratio of the Area (in %) of Russian Federation in 2005 to that in 2006?
Offer a terse response. 1. What is the ratio of the Area (in %) of Tajikistan in 2005 to that in 2006?
Ensure brevity in your answer.  1.03. What is the ratio of the Area (in %) in Korea (Democratic) in 2005 to that in 2007?
Offer a terse response. 1. What is the ratio of the Area (in %) of Portugal in 2005 to that in 2007?
Your answer should be very brief. 1.17. What is the ratio of the Area (in %) in Russian Federation in 2005 to that in 2007?
Your response must be concise. 1. What is the ratio of the Area (in %) in Tajikistan in 2005 to that in 2007?
Your response must be concise. 1.01. What is the ratio of the Area (in %) of Korea (Democratic) in 2006 to that in 2007?
Ensure brevity in your answer.  1. What is the ratio of the Area (in %) in Portugal in 2006 to that in 2007?
Keep it short and to the point. 1.15. What is the ratio of the Area (in %) of Tajikistan in 2006 to that in 2007?
Offer a terse response. 0.99. What is the difference between the highest and the second highest Area (in %) in Korea (Democratic)?
Give a very brief answer. 0. What is the difference between the highest and the second highest Area (in %) of Portugal?
Your answer should be very brief. 0.13. What is the difference between the highest and the second highest Area (in %) in Russian Federation?
Offer a terse response. 0.02. What is the difference between the highest and the second highest Area (in %) of Tajikistan?
Keep it short and to the point. 0.01. What is the difference between the highest and the lowest Area (in %) of Korea (Democratic)?
Your answer should be compact. 0.42. What is the difference between the highest and the lowest Area (in %) of Portugal?
Provide a succinct answer. 5.62. What is the difference between the highest and the lowest Area (in %) of Russian Federation?
Keep it short and to the point. 0.14. What is the difference between the highest and the lowest Area (in %) in Tajikistan?
Give a very brief answer. 0.33. 